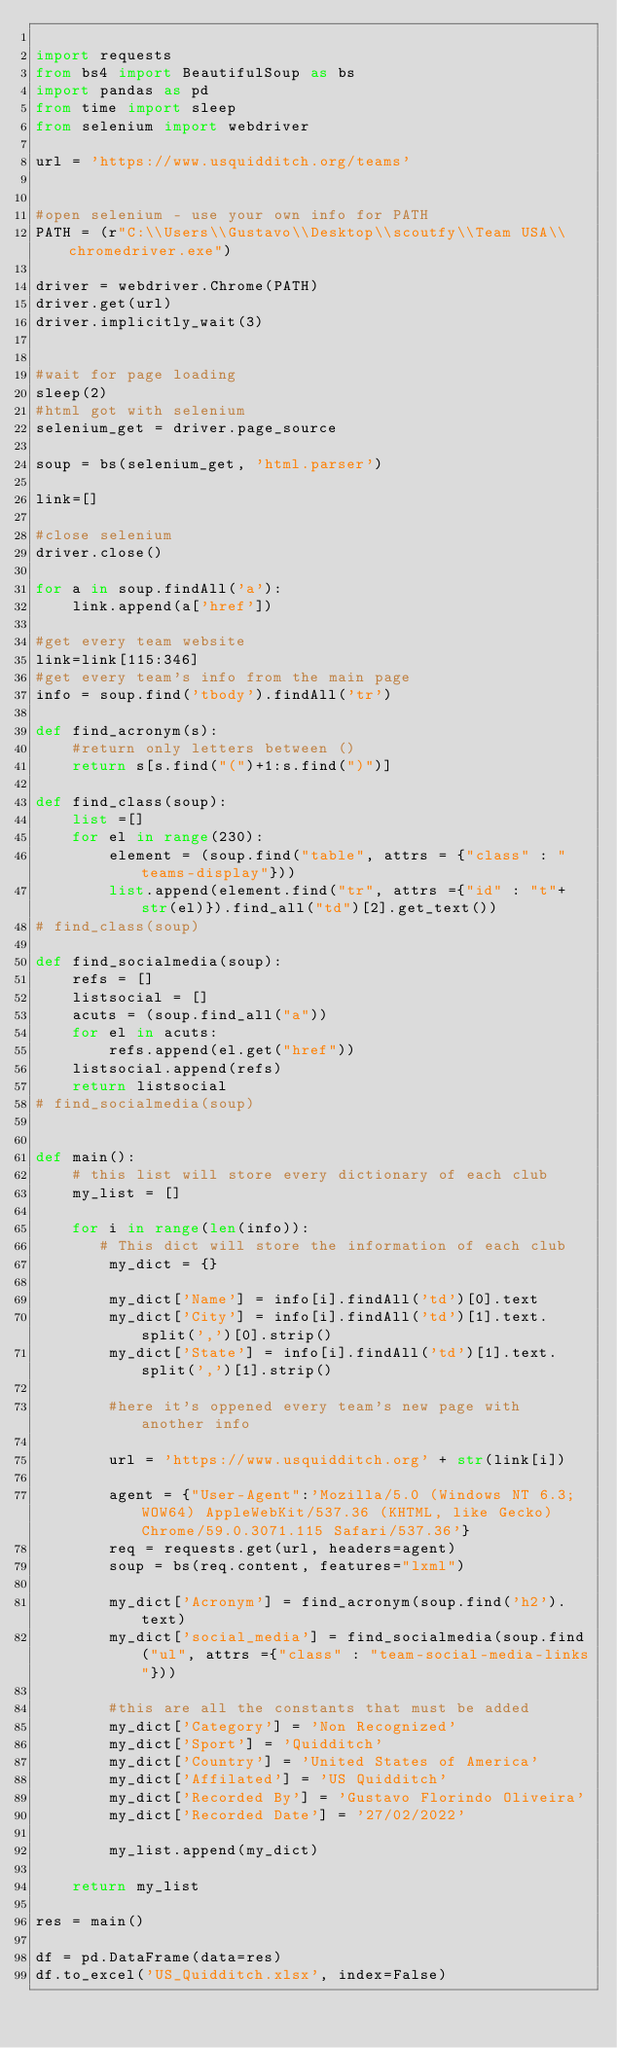Convert code to text. <code><loc_0><loc_0><loc_500><loc_500><_Python_>
import requests
from bs4 import BeautifulSoup as bs
import pandas as pd
from time import sleep
from selenium import webdriver

url = 'https://www.usquidditch.org/teams'


#open selenium - use your own info for PATH
PATH = (r"C:\\Users\\Gustavo\\Desktop\\scoutfy\\Team USA\\chromedriver.exe")

driver = webdriver.Chrome(PATH)
driver.get(url)
driver.implicitly_wait(3)


#wait for page loading
sleep(2)
#html got with selenium
selenium_get = driver.page_source

soup = bs(selenium_get, 'html.parser')

link=[]

#close selenium
driver.close() 

for a in soup.findAll('a'):
    link.append(a['href'])

#get every team website
link=link[115:346]
#get every team's info from the main page
info = soup.find('tbody').findAll('tr')

def find_acronym(s):
    #return only letters between ()
    return s[s.find("(")+1:s.find(")")]

def find_class(soup):
    list =[]
    for el in range(230):
        element = (soup.find("table", attrs = {"class" : "teams-display"}))
        list.append(element.find("tr", attrs ={"id" : "t"+str(el)}).find_all("td")[2].get_text())
# find_class(soup)

def find_socialmedia(soup):
    refs = []
    listsocial = []
    acuts = (soup.find_all("a"))
    for el in acuts:
        refs.append(el.get("href"))
    listsocial.append(refs)
    return listsocial
# find_socialmedia(soup)


def main():
    # this list will store every dictionary of each club
    my_list = []

    for i in range(len(info)):
       # This dict will store the information of each club
        my_dict = {}
        
        my_dict['Name'] = info[i].findAll('td')[0].text
        my_dict['City'] = info[i].findAll('td')[1].text.split(',')[0].strip()
        my_dict['State'] = info[i].findAll('td')[1].text.split(',')[1].strip()

        #here it's oppened every team's new page with another info
        
        url = 'https://www.usquidditch.org' + str(link[i])
        
        agent = {"User-Agent":'Mozilla/5.0 (Windows NT 6.3; WOW64) AppleWebKit/537.36 (KHTML, like Gecko) Chrome/59.0.3071.115 Safari/537.36'}
        req = requests.get(url, headers=agent)
        soup = bs(req.content, features="lxml") 
           
        my_dict['Acronym'] = find_acronym(soup.find('h2').text)
        my_dict['social_media'] = find_socialmedia(soup.find("ul", attrs ={"class" : "team-social-media-links"}))

        #this are all the constants that must be added
        my_dict['Category'] = 'Non Recognized'
        my_dict['Sport'] = 'Quidditch'
        my_dict['Country'] = 'United States of America'
        my_dict['Affilated'] = 'US Quidditch'
        my_dict['Recorded By'] = 'Gustavo Florindo Oliveira'
        my_dict['Recorded Date'] = '27/02/2022'

        my_list.append(my_dict)

    return my_list

res = main()

df = pd.DataFrame(data=res)
df.to_excel('US_Quidditch.xlsx', index=False)</code> 